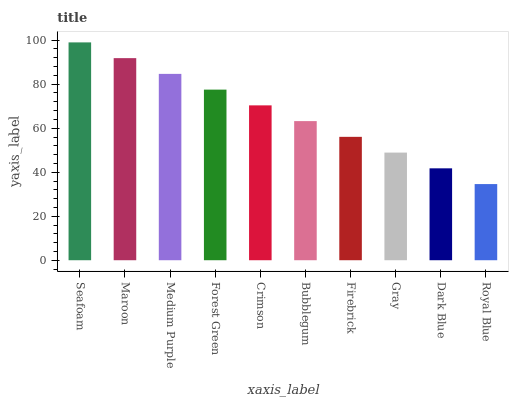Is Royal Blue the minimum?
Answer yes or no. Yes. Is Seafoam the maximum?
Answer yes or no. Yes. Is Maroon the minimum?
Answer yes or no. No. Is Maroon the maximum?
Answer yes or no. No. Is Seafoam greater than Maroon?
Answer yes or no. Yes. Is Maroon less than Seafoam?
Answer yes or no. Yes. Is Maroon greater than Seafoam?
Answer yes or no. No. Is Seafoam less than Maroon?
Answer yes or no. No. Is Crimson the high median?
Answer yes or no. Yes. Is Bubblegum the low median?
Answer yes or no. Yes. Is Royal Blue the high median?
Answer yes or no. No. Is Forest Green the low median?
Answer yes or no. No. 